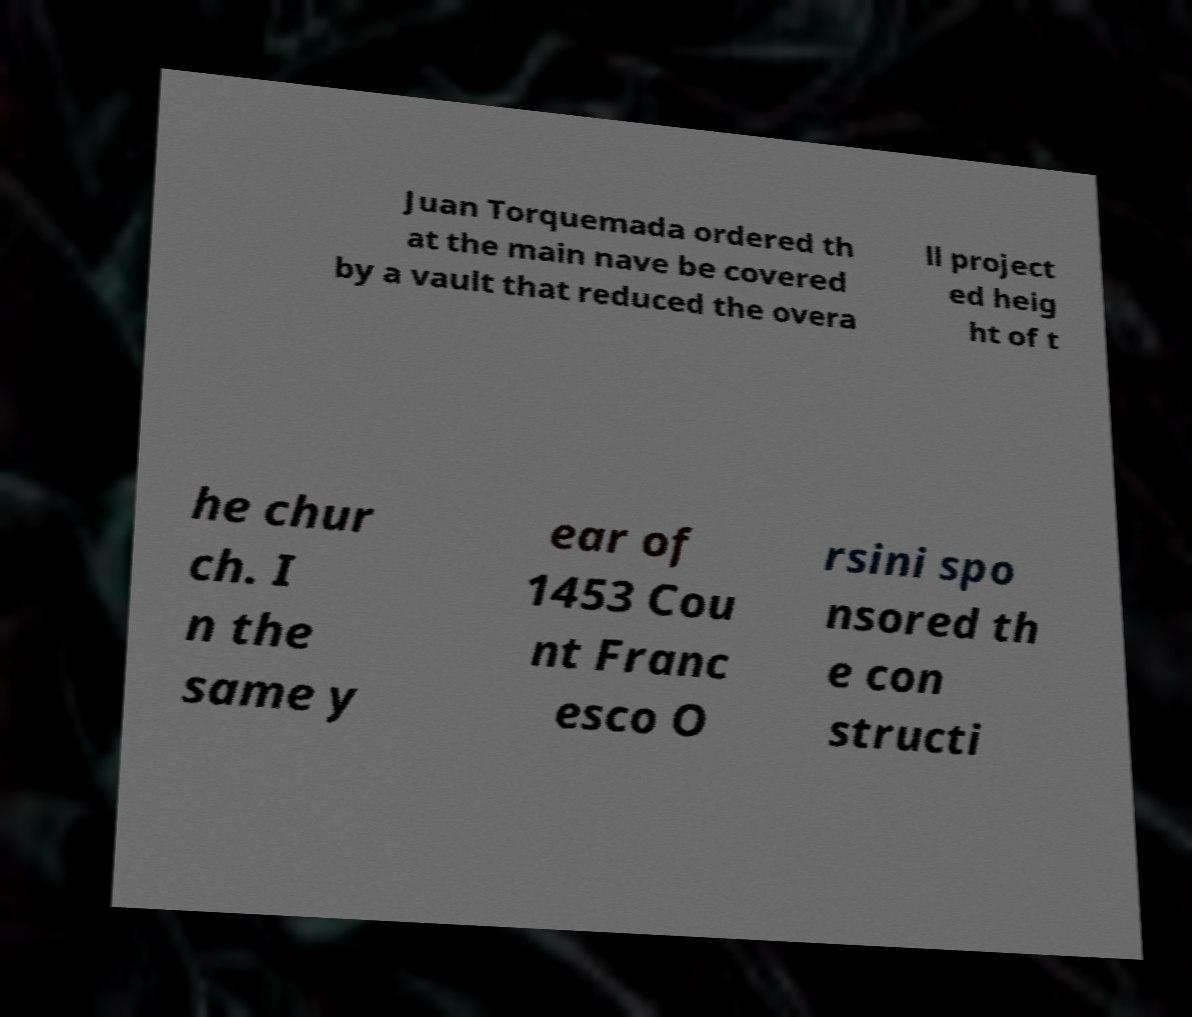Please read and relay the text visible in this image. What does it say? Juan Torquemada ordered th at the main nave be covered by a vault that reduced the overa ll project ed heig ht of t he chur ch. I n the same y ear of 1453 Cou nt Franc esco O rsini spo nsored th e con structi 